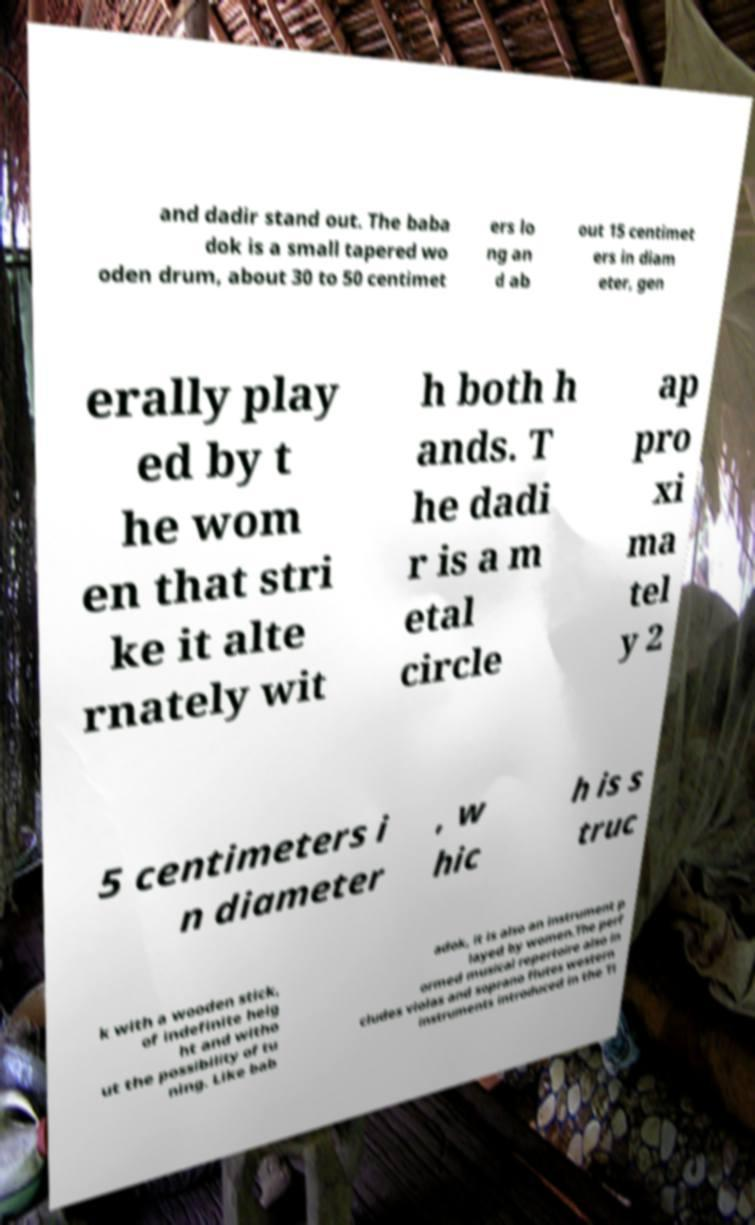Could you extract and type out the text from this image? and dadir stand out. The baba dok is a small tapered wo oden drum, about 30 to 50 centimet ers lo ng an d ab out 15 centimet ers in diam eter, gen erally play ed by t he wom en that stri ke it alte rnately wit h both h ands. T he dadi r is a m etal circle ap pro xi ma tel y 2 5 centimeters i n diameter , w hic h is s truc k with a wooden stick, of indefinite heig ht and witho ut the possibility of tu ning. Like bab adok, it is also an instrument p layed by women.The perf ormed musical repertoire also in cludes violas and soprano flutes western instruments introduced in the Ti 